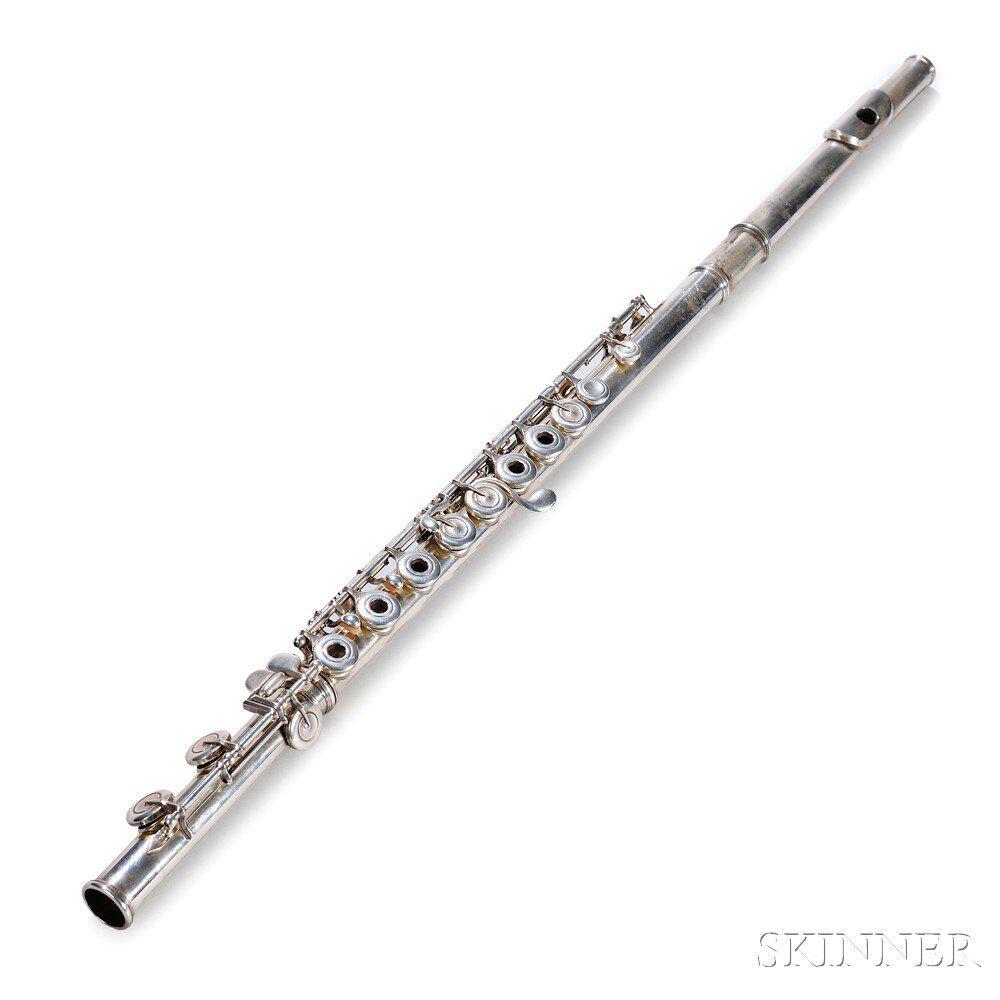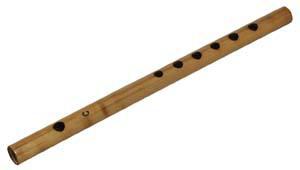The first image is the image on the left, the second image is the image on the right. Examine the images to the left and right. Is the description "The left image contains at least two musical instruments." accurate? Answer yes or no. No. The first image is the image on the left, the second image is the image on the right. Assess this claim about the two images: "No image contains more than one instrument, and one instrument is light wood with holes down its length, and the other is silver with small button-keys on tabs.". Correct or not? Answer yes or no. Yes. 